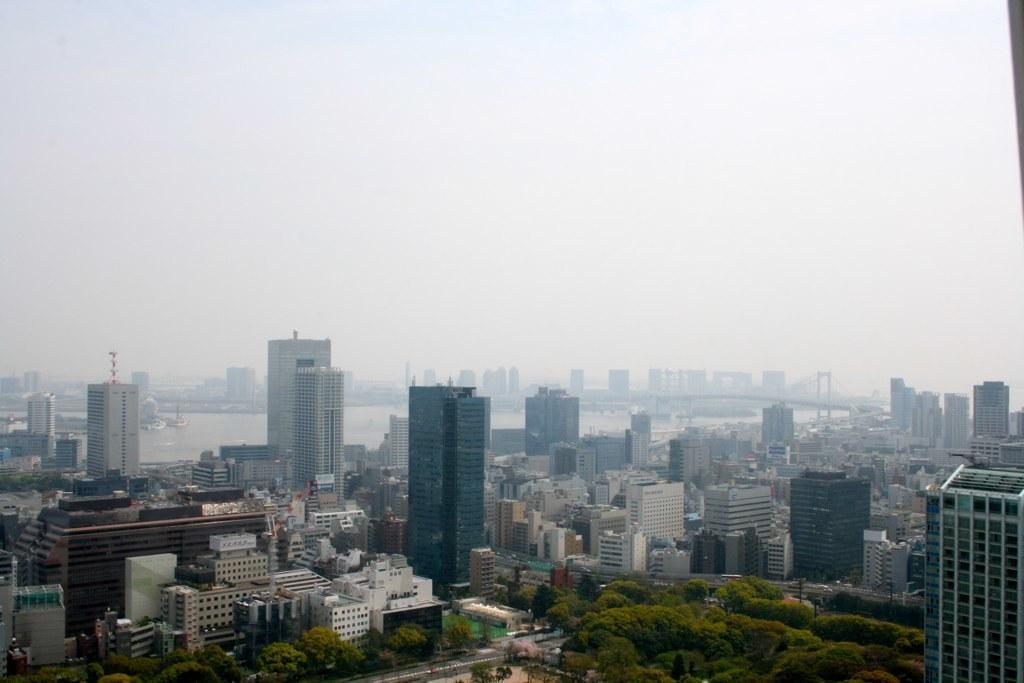Can you describe this image briefly? In this picture there are buildings in the center of the image and there are trees at the bottom side of the image. 